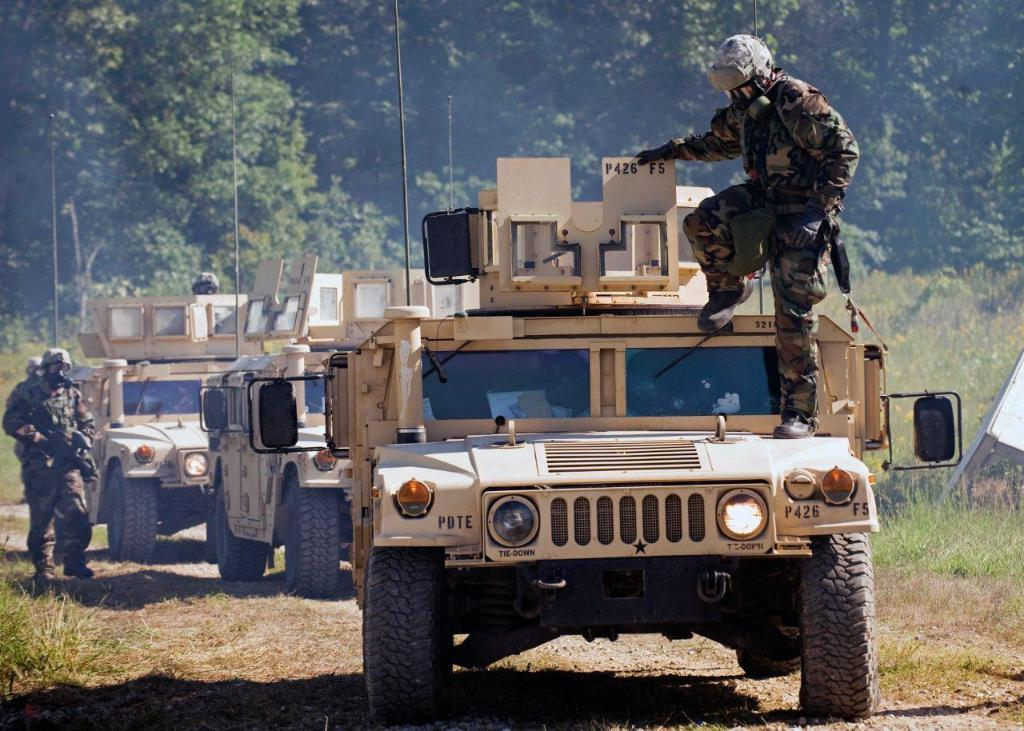What types of objects are present in the image? There are vehicles and soldiers in the image. What can be seen on the ground in the image? There is a path and grass visible in the image. What is visible in the background of the image? There are trees in the background of the image. Where is the nest located in the image? There is no nest present in the image. What type of table can be seen in the image? There is no table present in the image. 